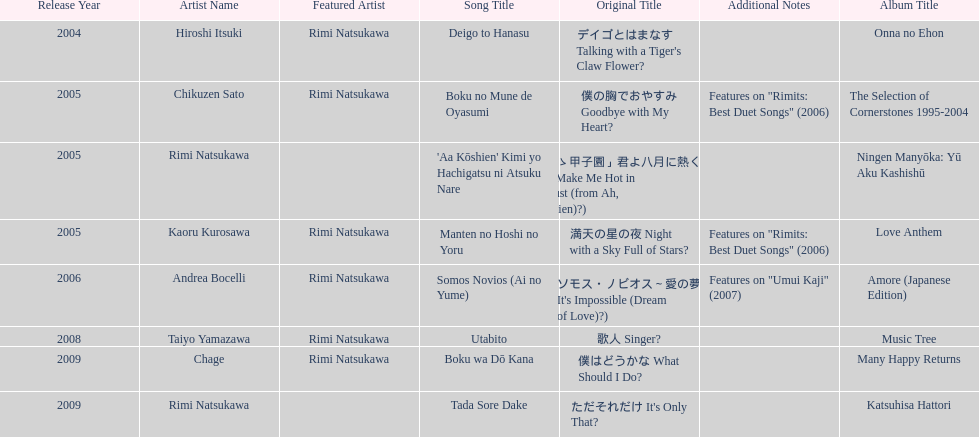What was the album released immediately before the one that had boku wa do kana on it? Music Tree. 